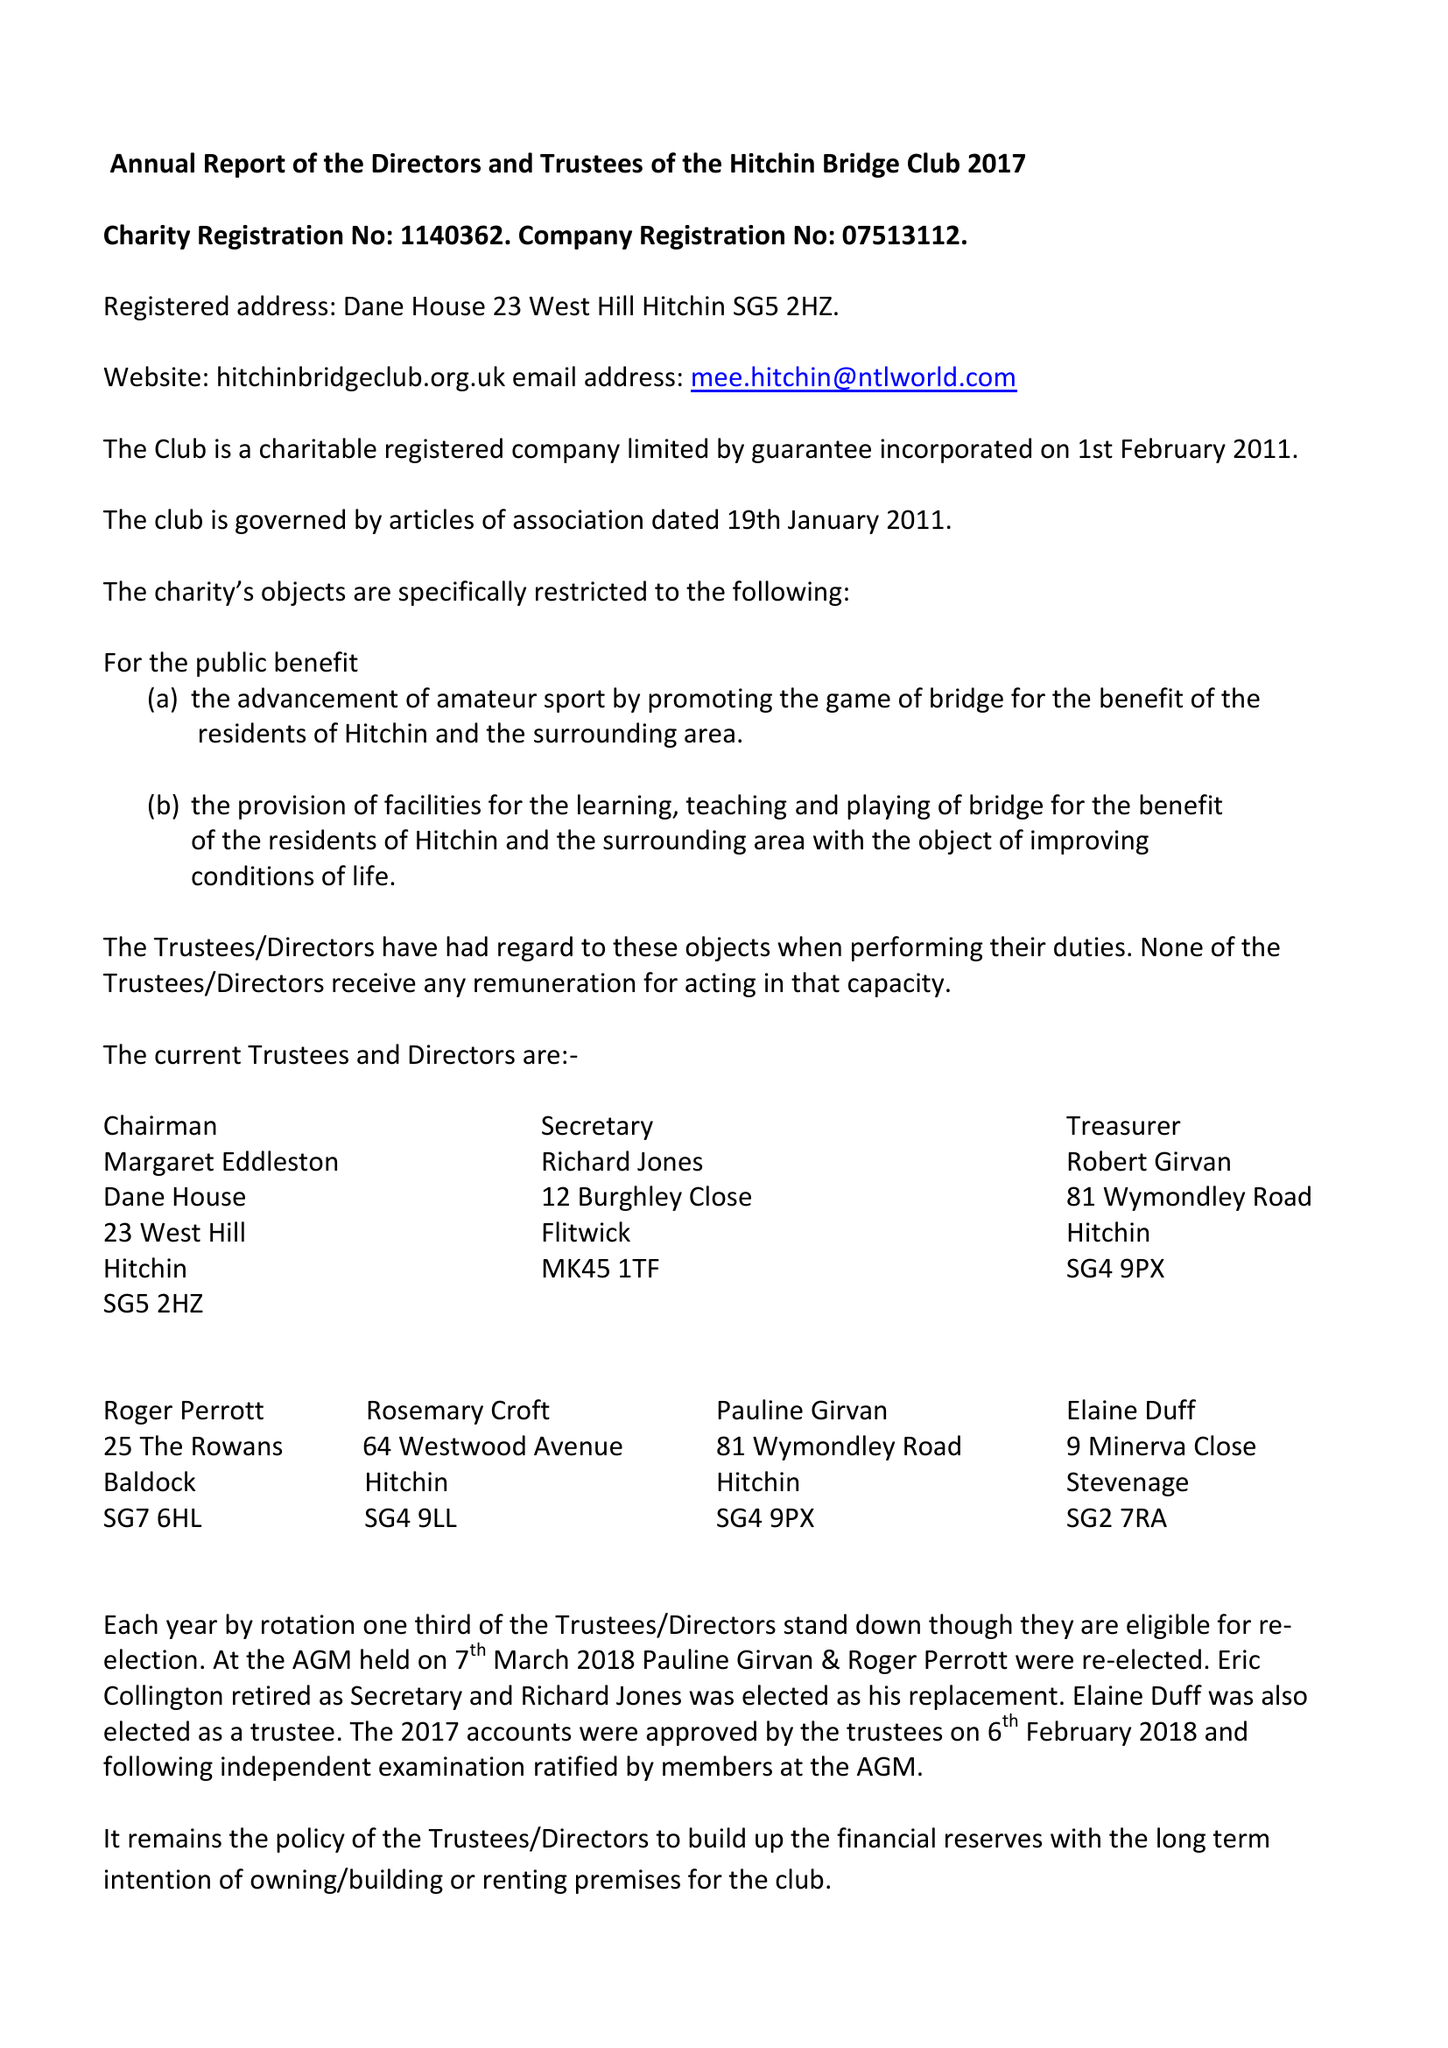What is the value for the address__postcode?
Answer the question using a single word or phrase. SG5 2HZ 